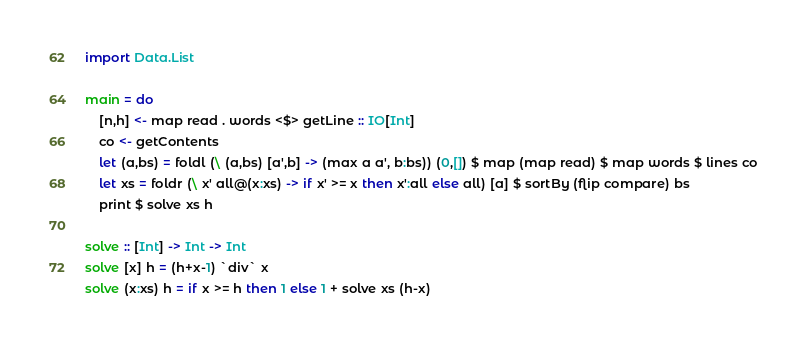Convert code to text. <code><loc_0><loc_0><loc_500><loc_500><_Haskell_>import Data.List

main = do
    [n,h] <- map read . words <$> getLine :: IO[Int]
    co <- getContents
    let (a,bs) = foldl (\ (a,bs) [a',b] -> (max a a', b:bs)) (0,[]) $ map (map read) $ map words $ lines co
    let xs = foldr (\ x' all@(x:xs) -> if x' >= x then x':all else all) [a] $ sortBy (flip compare) bs
    print $ solve xs h

solve :: [Int] -> Int -> Int
solve [x] h = (h+x-1) `div` x
solve (x:xs) h = if x >= h then 1 else 1 + solve xs (h-x)
</code> 